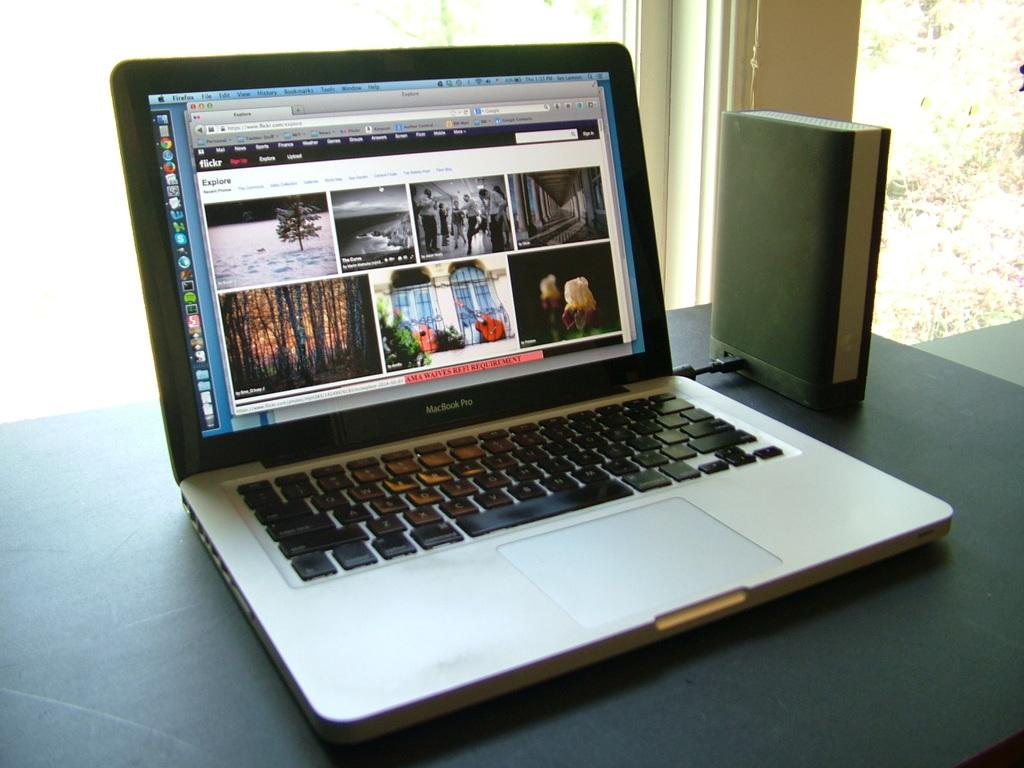<image>
Create a compact narrative representing the image presented. Macbookk Pro laptop with a screen showing flickr pictures. 